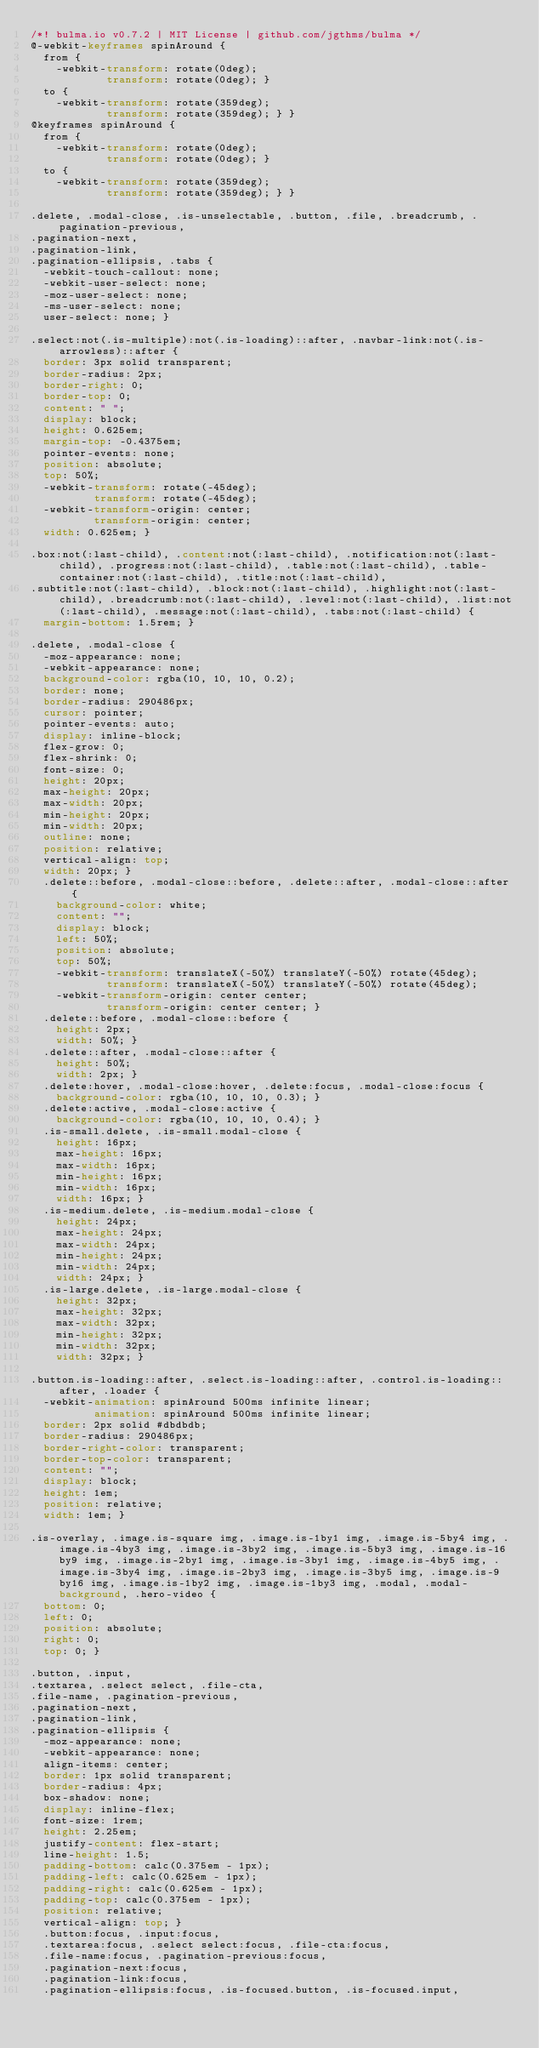<code> <loc_0><loc_0><loc_500><loc_500><_CSS_>/*! bulma.io v0.7.2 | MIT License | github.com/jgthms/bulma */
@-webkit-keyframes spinAround {
  from {
    -webkit-transform: rotate(0deg);
            transform: rotate(0deg); }
  to {
    -webkit-transform: rotate(359deg);
            transform: rotate(359deg); } }
@keyframes spinAround {
  from {
    -webkit-transform: rotate(0deg);
            transform: rotate(0deg); }
  to {
    -webkit-transform: rotate(359deg);
            transform: rotate(359deg); } }

.delete, .modal-close, .is-unselectable, .button, .file, .breadcrumb, .pagination-previous,
.pagination-next,
.pagination-link,
.pagination-ellipsis, .tabs {
  -webkit-touch-callout: none;
  -webkit-user-select: none;
  -moz-user-select: none;
  -ms-user-select: none;
  user-select: none; }

.select:not(.is-multiple):not(.is-loading)::after, .navbar-link:not(.is-arrowless)::after {
  border: 3px solid transparent;
  border-radius: 2px;
  border-right: 0;
  border-top: 0;
  content: " ";
  display: block;
  height: 0.625em;
  margin-top: -0.4375em;
  pointer-events: none;
  position: absolute;
  top: 50%;
  -webkit-transform: rotate(-45deg);
          transform: rotate(-45deg);
  -webkit-transform-origin: center;
          transform-origin: center;
  width: 0.625em; }

.box:not(:last-child), .content:not(:last-child), .notification:not(:last-child), .progress:not(:last-child), .table:not(:last-child), .table-container:not(:last-child), .title:not(:last-child),
.subtitle:not(:last-child), .block:not(:last-child), .highlight:not(:last-child), .breadcrumb:not(:last-child), .level:not(:last-child), .list:not(:last-child), .message:not(:last-child), .tabs:not(:last-child) {
  margin-bottom: 1.5rem; }

.delete, .modal-close {
  -moz-appearance: none;
  -webkit-appearance: none;
  background-color: rgba(10, 10, 10, 0.2);
  border: none;
  border-radius: 290486px;
  cursor: pointer;
  pointer-events: auto;
  display: inline-block;
  flex-grow: 0;
  flex-shrink: 0;
  font-size: 0;
  height: 20px;
  max-height: 20px;
  max-width: 20px;
  min-height: 20px;
  min-width: 20px;
  outline: none;
  position: relative;
  vertical-align: top;
  width: 20px; }
  .delete::before, .modal-close::before, .delete::after, .modal-close::after {
    background-color: white;
    content: "";
    display: block;
    left: 50%;
    position: absolute;
    top: 50%;
    -webkit-transform: translateX(-50%) translateY(-50%) rotate(45deg);
            transform: translateX(-50%) translateY(-50%) rotate(45deg);
    -webkit-transform-origin: center center;
            transform-origin: center center; }
  .delete::before, .modal-close::before {
    height: 2px;
    width: 50%; }
  .delete::after, .modal-close::after {
    height: 50%;
    width: 2px; }
  .delete:hover, .modal-close:hover, .delete:focus, .modal-close:focus {
    background-color: rgba(10, 10, 10, 0.3); }
  .delete:active, .modal-close:active {
    background-color: rgba(10, 10, 10, 0.4); }
  .is-small.delete, .is-small.modal-close {
    height: 16px;
    max-height: 16px;
    max-width: 16px;
    min-height: 16px;
    min-width: 16px;
    width: 16px; }
  .is-medium.delete, .is-medium.modal-close {
    height: 24px;
    max-height: 24px;
    max-width: 24px;
    min-height: 24px;
    min-width: 24px;
    width: 24px; }
  .is-large.delete, .is-large.modal-close {
    height: 32px;
    max-height: 32px;
    max-width: 32px;
    min-height: 32px;
    min-width: 32px;
    width: 32px; }

.button.is-loading::after, .select.is-loading::after, .control.is-loading::after, .loader {
  -webkit-animation: spinAround 500ms infinite linear;
          animation: spinAround 500ms infinite linear;
  border: 2px solid #dbdbdb;
  border-radius: 290486px;
  border-right-color: transparent;
  border-top-color: transparent;
  content: "";
  display: block;
  height: 1em;
  position: relative;
  width: 1em; }

.is-overlay, .image.is-square img, .image.is-1by1 img, .image.is-5by4 img, .image.is-4by3 img, .image.is-3by2 img, .image.is-5by3 img, .image.is-16by9 img, .image.is-2by1 img, .image.is-3by1 img, .image.is-4by5 img, .image.is-3by4 img, .image.is-2by3 img, .image.is-3by5 img, .image.is-9by16 img, .image.is-1by2 img, .image.is-1by3 img, .modal, .modal-background, .hero-video {
  bottom: 0;
  left: 0;
  position: absolute;
  right: 0;
  top: 0; }

.button, .input,
.textarea, .select select, .file-cta,
.file-name, .pagination-previous,
.pagination-next,
.pagination-link,
.pagination-ellipsis {
  -moz-appearance: none;
  -webkit-appearance: none;
  align-items: center;
  border: 1px solid transparent;
  border-radius: 4px;
  box-shadow: none;
  display: inline-flex;
  font-size: 1rem;
  height: 2.25em;
  justify-content: flex-start;
  line-height: 1.5;
  padding-bottom: calc(0.375em - 1px);
  padding-left: calc(0.625em - 1px);
  padding-right: calc(0.625em - 1px);
  padding-top: calc(0.375em - 1px);
  position: relative;
  vertical-align: top; }
  .button:focus, .input:focus,
  .textarea:focus, .select select:focus, .file-cta:focus,
  .file-name:focus, .pagination-previous:focus,
  .pagination-next:focus,
  .pagination-link:focus,
  .pagination-ellipsis:focus, .is-focused.button, .is-focused.input,</code> 